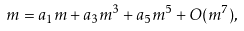Convert formula to latex. <formula><loc_0><loc_0><loc_500><loc_500>m = a _ { 1 } m + a _ { 3 } m ^ { 3 } + a _ { 5 } m ^ { 5 } + O ( m ^ { 7 } ) ,</formula> 